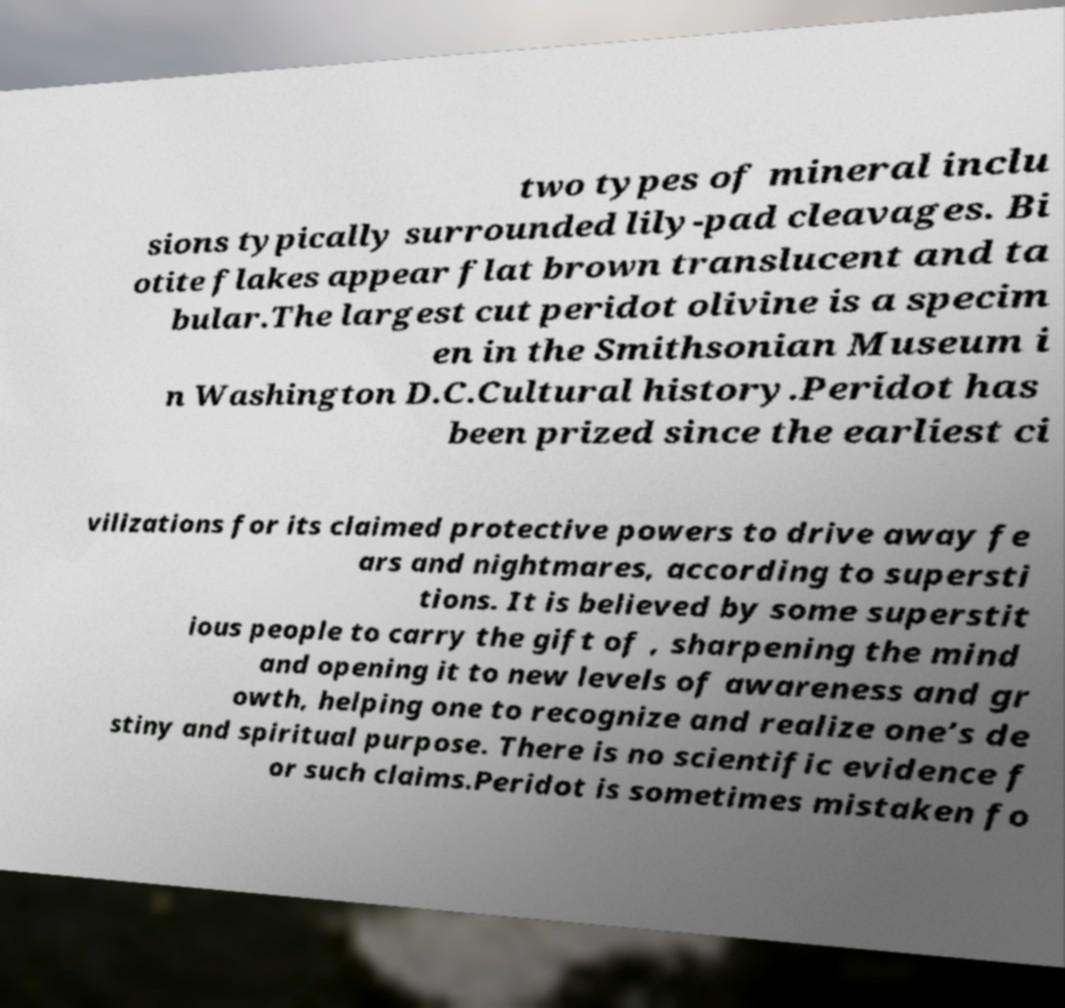Can you read and provide the text displayed in the image?This photo seems to have some interesting text. Can you extract and type it out for me? two types of mineral inclu sions typically surrounded lily-pad cleavages. Bi otite flakes appear flat brown translucent and ta bular.The largest cut peridot olivine is a specim en in the Smithsonian Museum i n Washington D.C.Cultural history.Peridot has been prized since the earliest ci vilizations for its claimed protective powers to drive away fe ars and nightmares, according to supersti tions. It is believed by some superstit ious people to carry the gift of , sharpening the mind and opening it to new levels of awareness and gr owth, helping one to recognize and realize one’s de stiny and spiritual purpose. There is no scientific evidence f or such claims.Peridot is sometimes mistaken fo 